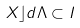Convert formula to latex. <formula><loc_0><loc_0><loc_500><loc_500>X \rfloor d \Lambda \subset I</formula> 